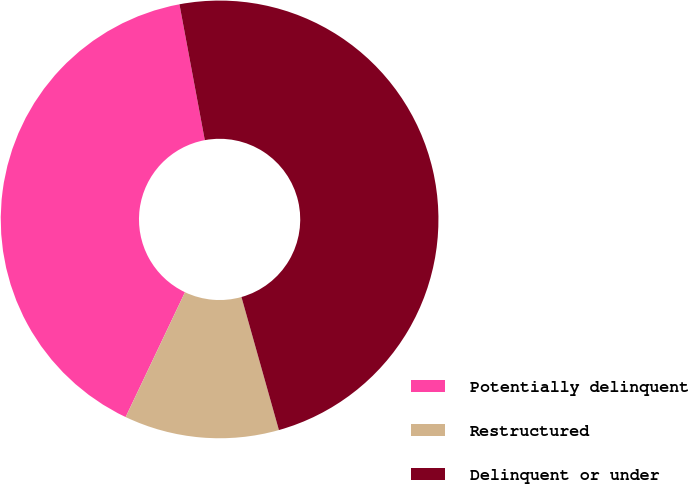Convert chart to OTSL. <chart><loc_0><loc_0><loc_500><loc_500><pie_chart><fcel>Potentially delinquent<fcel>Restructured<fcel>Delinquent or under<nl><fcel>40.0%<fcel>11.43%<fcel>48.57%<nl></chart> 